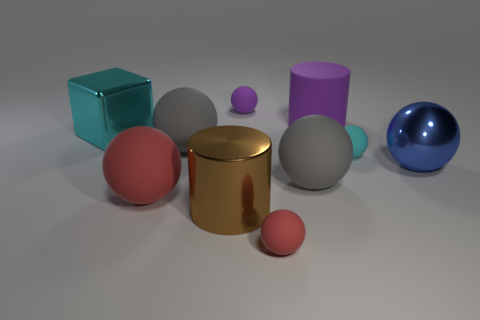How many red spheres must be subtracted to get 1 red spheres? 1 Subtract all red spheres. How many spheres are left? 5 Subtract all red spheres. How many spheres are left? 5 Subtract all cyan balls. Subtract all green blocks. How many balls are left? 6 Subtract all cylinders. How many objects are left? 8 Subtract 0 cyan cylinders. How many objects are left? 10 Subtract all tiny things. Subtract all small purple rubber cubes. How many objects are left? 7 Add 6 big red rubber things. How many big red rubber things are left? 7 Add 9 yellow cylinders. How many yellow cylinders exist? 9 